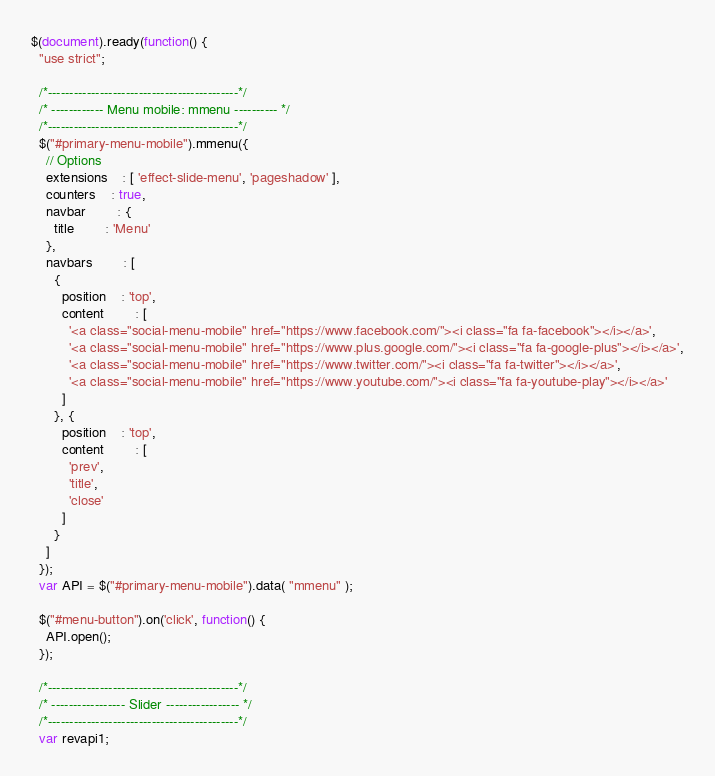Convert code to text. <code><loc_0><loc_0><loc_500><loc_500><_JavaScript_>$(document).ready(function() {
  "use strict";

  /*--------------------------------------------*/
  /* ------------ Menu mobile: mmenu ---------- */
  /*--------------------------------------------*/
  $("#primary-menu-mobile").mmenu({
    // Options
    extensions	: [ 'effect-slide-menu', 'pageshadow' ],
    counters	: true,
    navbar 		: {
      title		: 'Menu'
    },
    navbars		: [
      {
        position	: 'top',
        content		: [
          '<a class="social-menu-mobile" href="https://www.facebook.com/"><i class="fa fa-facebook"></i></a>',
          '<a class="social-menu-mobile" href="https://www.plus.google.com/"><i class="fa fa-google-plus"></i></a>',
          '<a class="social-menu-mobile" href="https://www.twitter.com/"><i class="fa fa-twitter"></i></a>',
          '<a class="social-menu-mobile" href="https://www.youtube.com/"><i class="fa fa-youtube-play"></i></a>'
        ]
      }, {
        position	: 'top',
        content		: [
          'prev',
          'title',
          'close'
        ]
      }
    ]
  });
  var API = $("#primary-menu-mobile").data( "mmenu" );

  $("#menu-button").on('click', function() {
    API.open();
  });

  /*--------------------------------------------*/
  /* ----------------- Slider ----------------- */
  /*--------------------------------------------*/
  var revapi1;</code> 